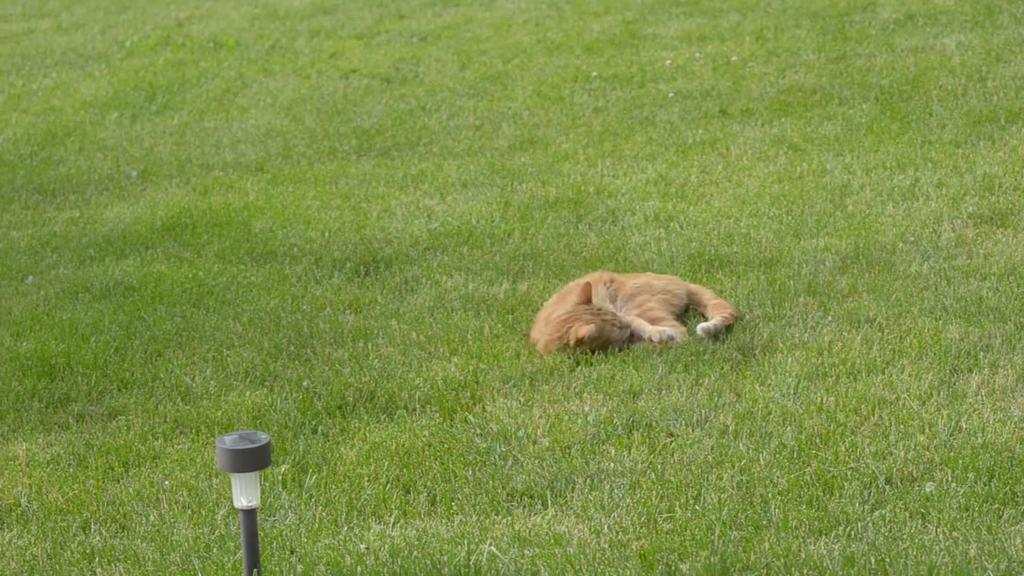What animal can be seen in the image? There is a cat in the image. Where is the cat located? The cat is lying on a grass field. What object is present at the bottom of the image? There is a pole at the bottom of the image. What type of glue is the cat using to stick the toothpaste to the knot in the image? There is no glue, toothpaste, or knot present in the image. The image only features a cat lying on a grass field and a pole at the bottom. 